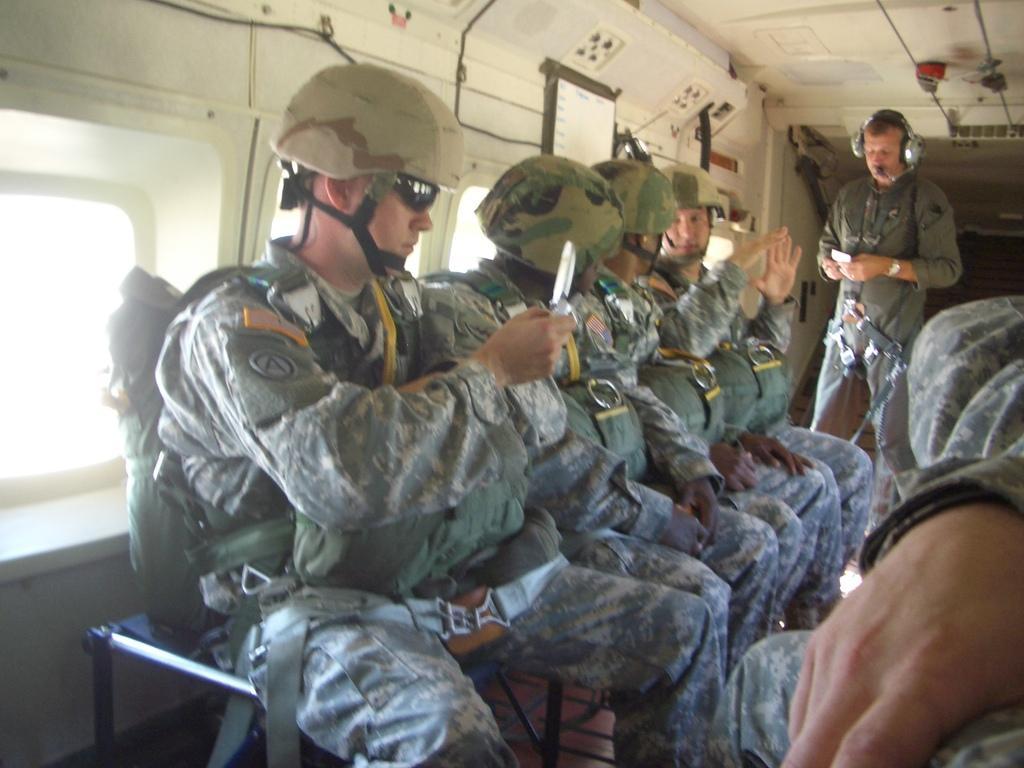In one or two sentences, can you explain what this image depicts? In this picture we can see few people, few are sitting and a man is standing, on the left side of the image we can see a man, he is holding an object. 